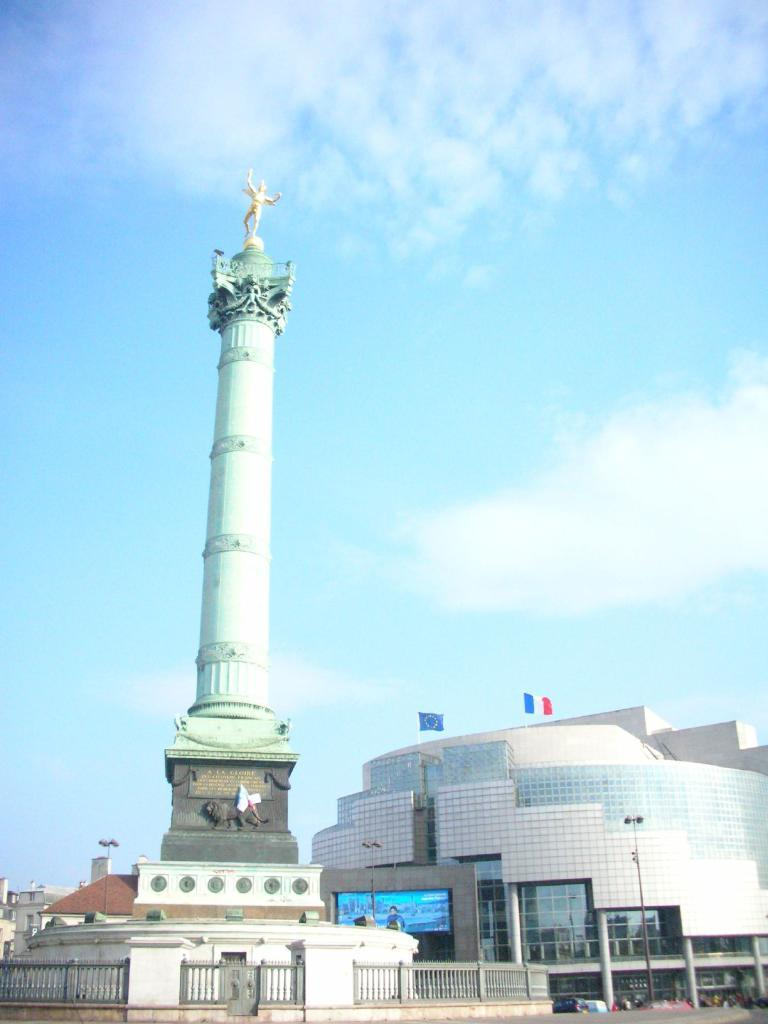What can be seen in the sky in the background of the image? There are clouds in the sky in the background of the image. What type of structures are present in the image? There are buildings, a tower, and statues in the image. What are some other objects visible in the image? There are poles, flags, a screen, and various other objects in the image. What might be used for protection or support in the image? There is railing in the image that could be used for protection or support. What type of drink is being served in the image? There is no drink being served in the image; it primarily features buildings, clouds, and other structures. What color is the paint used on the statues in the image? There is no paint visible on the statues in the image; they are made of a material that does not require paint. 